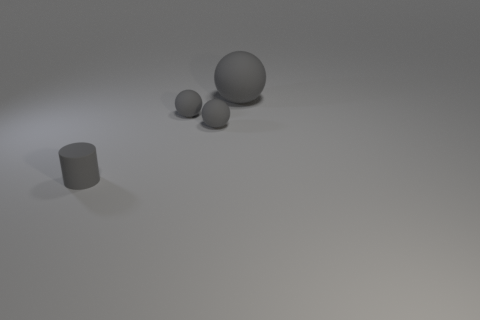Is there a small rubber ball of the same color as the big thing?
Give a very brief answer. Yes. How many tiny objects are either matte cylinders or rubber balls?
Keep it short and to the point. 3. How many big blue rubber balls are there?
Give a very brief answer. 0. Are there any tiny gray things behind the tiny gray cylinder?
Your answer should be compact. Yes. How many tiny objects have the same material as the tiny gray cylinder?
Your answer should be very brief. 2. Is the number of small rubber objects that are to the left of the small rubber cylinder less than the number of tiny gray rubber cylinders that are in front of the big gray matte ball?
Your response must be concise. Yes. There is a big object that is the same color as the small matte cylinder; what shape is it?
Give a very brief answer. Sphere. What number of shiny things are either tiny cylinders or large gray things?
Offer a terse response. 0. Is there anything else of the same color as the small cylinder?
Ensure brevity in your answer.  Yes. The gray cylinder has what size?
Offer a very short reply. Small. 